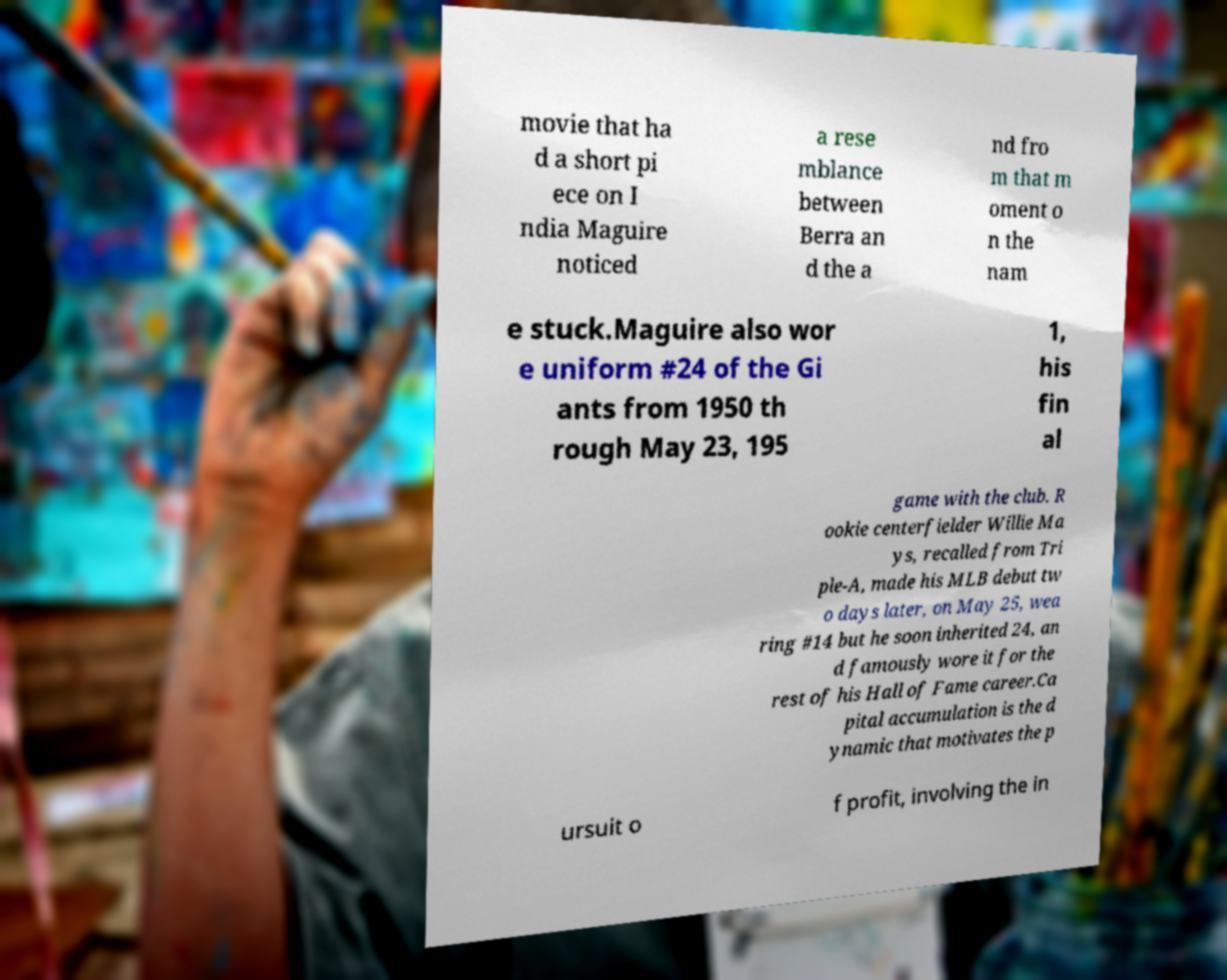For documentation purposes, I need the text within this image transcribed. Could you provide that? movie that ha d a short pi ece on I ndia Maguire noticed a rese mblance between Berra an d the a nd fro m that m oment o n the nam e stuck.Maguire also wor e uniform #24 of the Gi ants from 1950 th rough May 23, 195 1, his fin al game with the club. R ookie centerfielder Willie Ma ys, recalled from Tri ple-A, made his MLB debut tw o days later, on May 25, wea ring #14 but he soon inherited 24, an d famously wore it for the rest of his Hall of Fame career.Ca pital accumulation is the d ynamic that motivates the p ursuit o f profit, involving the in 